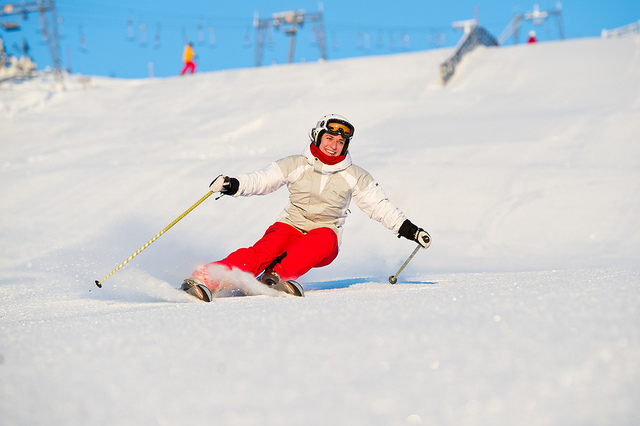What kind of safety gear should one wear while skiing? For skiing, it's important to wear a helmet to protect your head, goggles to shield your eyes from glare and snow, and appropriate waterproof and insulated clothing. Additionally, gloves or mittens, ski boots, and sometimes back protectors or padded shorts can offer further protection. 